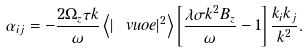<formula> <loc_0><loc_0><loc_500><loc_500>\alpha _ { i j } = - \frac { 2 \Omega _ { z } \tau k } { \omega } \left < | \ v u o e | ^ { 2 } \right > \left [ \frac { \lambda \sigma k ^ { 2 } B _ { z } } { \omega } - 1 \right ] \frac { k _ { i } k _ { j } } { k ^ { 2 } } .</formula> 